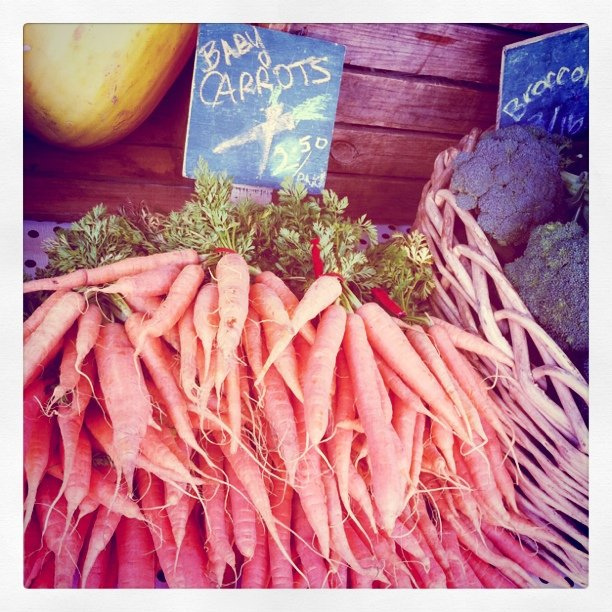Besides carrots, what other vegetables do I see in the image? In addition to the carrots, there is broccoli and what appears to be a squash visible on the table, indicating a variety of fresh produce for sale. Can you tell me a bit more about the other vegetable present? Certainly, the broccoli appears to have a rich green color characteristic of fresh and healthy crowns, ideal for a wide range of dishes from steaming to roasting. 